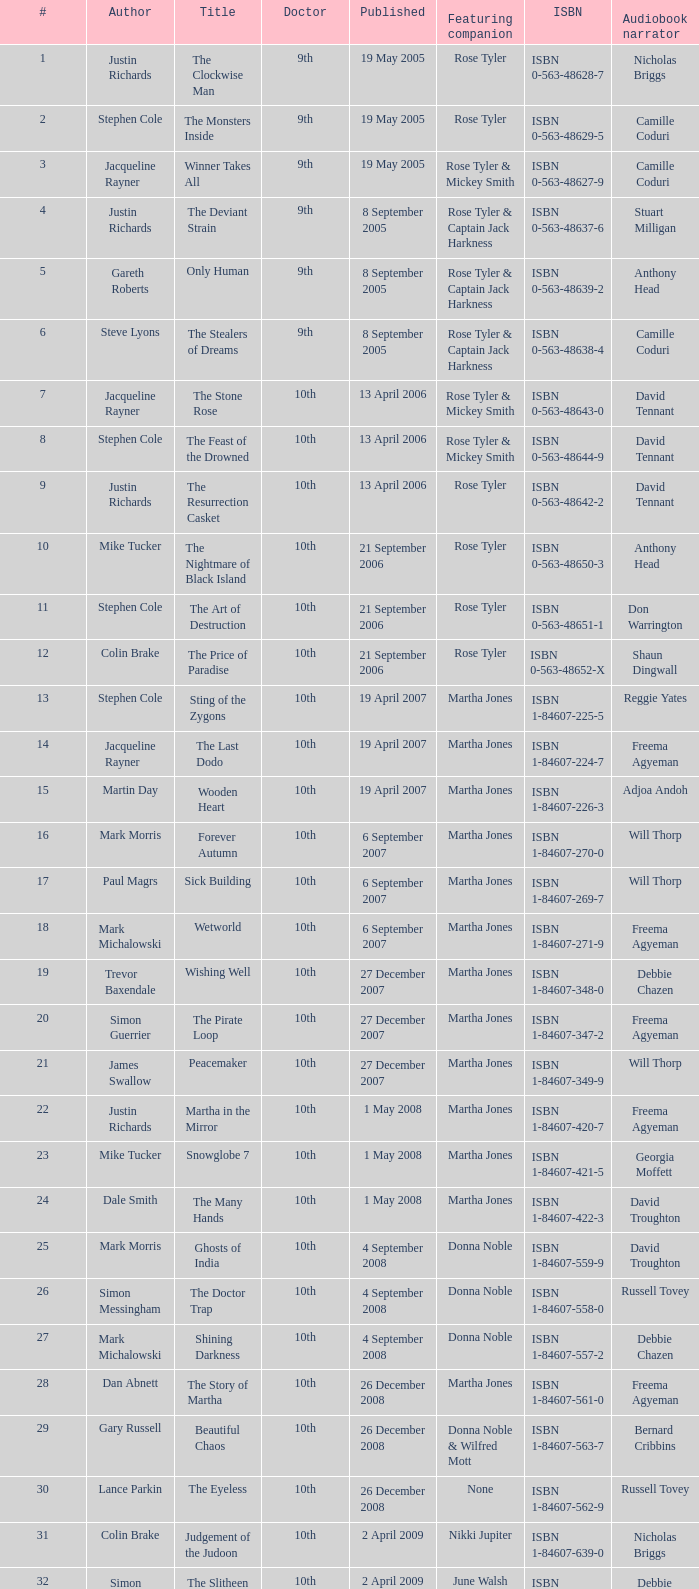What is the title of book number 8? The Feast of the Drowned. 